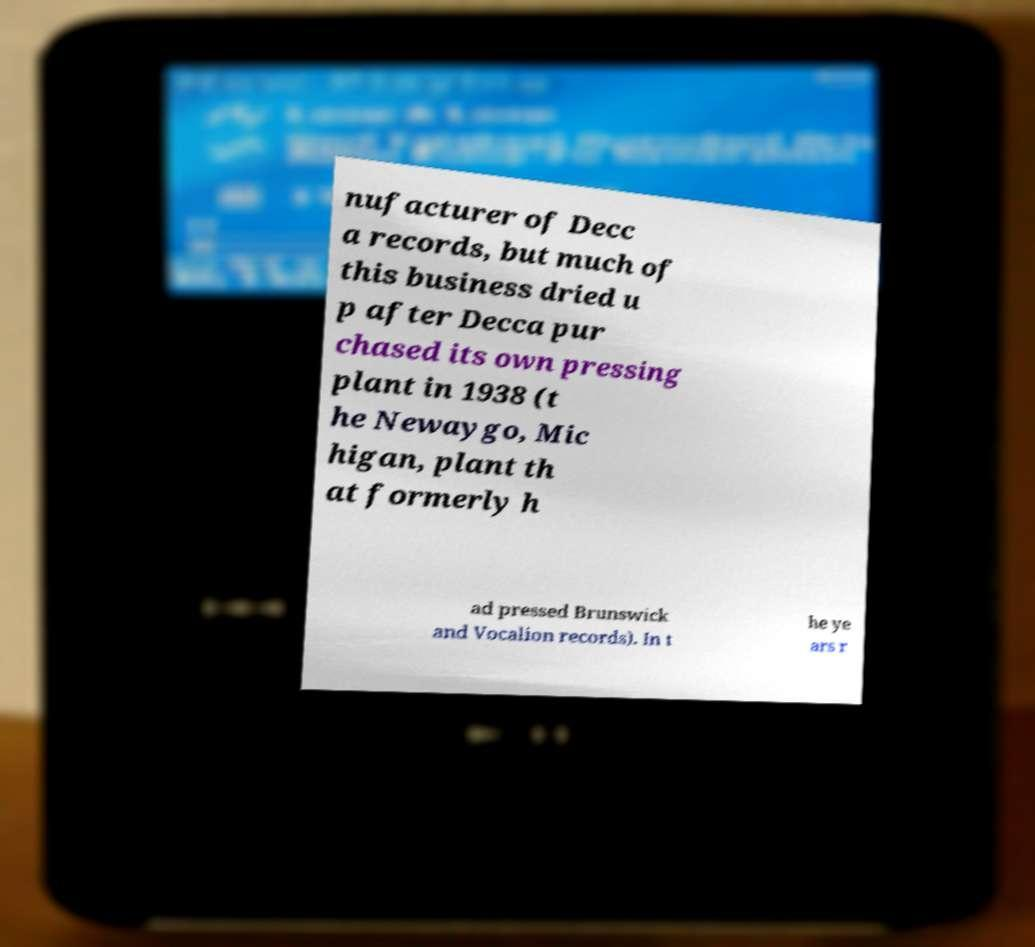Please identify and transcribe the text found in this image. nufacturer of Decc a records, but much of this business dried u p after Decca pur chased its own pressing plant in 1938 (t he Newaygo, Mic higan, plant th at formerly h ad pressed Brunswick and Vocalion records). In t he ye ars r 